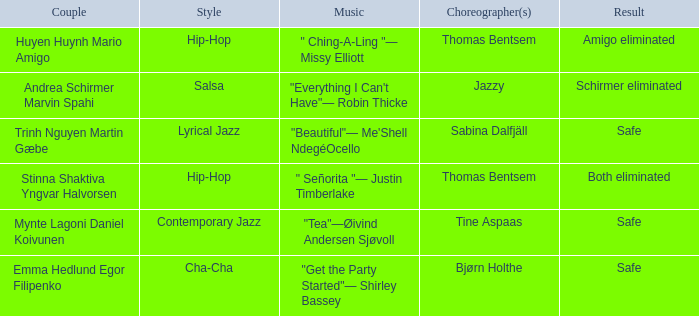What is the music for choreographer sabina dalfjäll? "Beautiful"— Me'Shell NdegéOcello. 